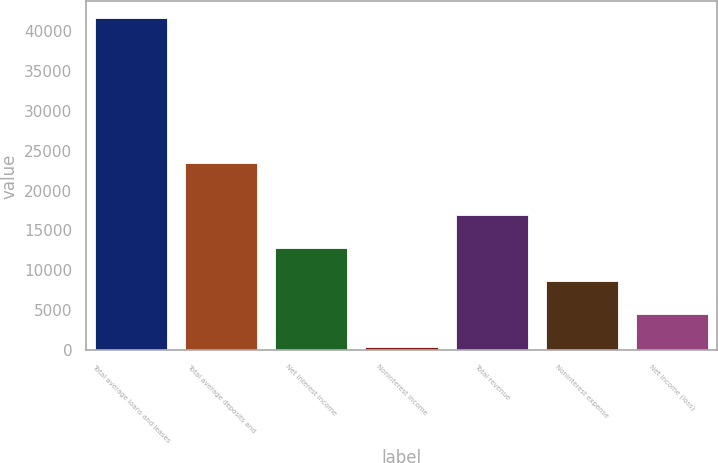Convert chart. <chart><loc_0><loc_0><loc_500><loc_500><bar_chart><fcel>Total average loans and leases<fcel>Total average deposits and<fcel>Net interest income<fcel>Noninterest income<fcel>Total revenue<fcel>Noninterest expense<fcel>Net income (loss)<nl><fcel>41593<fcel>23473<fcel>12768.4<fcel>415<fcel>16886.2<fcel>8650.6<fcel>4532.8<nl></chart> 